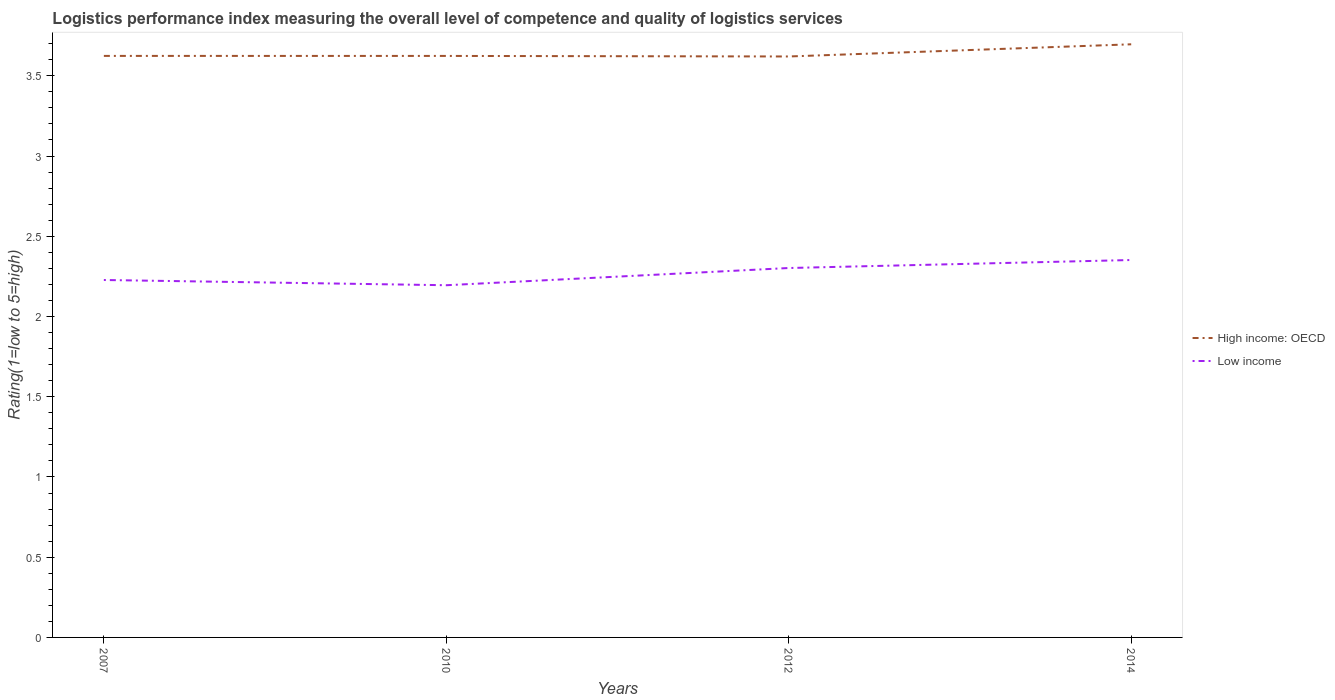How many different coloured lines are there?
Give a very brief answer. 2. Is the number of lines equal to the number of legend labels?
Provide a short and direct response. Yes. Across all years, what is the maximum Logistic performance index in Low income?
Your answer should be very brief. 2.19. In which year was the Logistic performance index in High income: OECD maximum?
Provide a short and direct response. 2012. What is the total Logistic performance index in High income: OECD in the graph?
Offer a very short reply. -0.07. What is the difference between the highest and the second highest Logistic performance index in Low income?
Make the answer very short. 0.16. What is the difference between the highest and the lowest Logistic performance index in High income: OECD?
Offer a very short reply. 1. How many lines are there?
Give a very brief answer. 2. How many years are there in the graph?
Offer a terse response. 4. What is the difference between two consecutive major ticks on the Y-axis?
Offer a very short reply. 0.5. Does the graph contain any zero values?
Offer a very short reply. No. Does the graph contain grids?
Ensure brevity in your answer.  No. How many legend labels are there?
Make the answer very short. 2. How are the legend labels stacked?
Provide a short and direct response. Vertical. What is the title of the graph?
Keep it short and to the point. Logistics performance index measuring the overall level of competence and quality of logistics services. Does "Nicaragua" appear as one of the legend labels in the graph?
Your answer should be compact. No. What is the label or title of the Y-axis?
Give a very brief answer. Rating(1=low to 5=high). What is the Rating(1=low to 5=high) in High income: OECD in 2007?
Keep it short and to the point. 3.62. What is the Rating(1=low to 5=high) in Low income in 2007?
Your response must be concise. 2.23. What is the Rating(1=low to 5=high) of High income: OECD in 2010?
Offer a very short reply. 3.62. What is the Rating(1=low to 5=high) in Low income in 2010?
Give a very brief answer. 2.19. What is the Rating(1=low to 5=high) of High income: OECD in 2012?
Your response must be concise. 3.62. What is the Rating(1=low to 5=high) of Low income in 2012?
Keep it short and to the point. 2.3. What is the Rating(1=low to 5=high) in High income: OECD in 2014?
Offer a very short reply. 3.7. What is the Rating(1=low to 5=high) of Low income in 2014?
Give a very brief answer. 2.35. Across all years, what is the maximum Rating(1=low to 5=high) of High income: OECD?
Ensure brevity in your answer.  3.7. Across all years, what is the maximum Rating(1=low to 5=high) in Low income?
Make the answer very short. 2.35. Across all years, what is the minimum Rating(1=low to 5=high) in High income: OECD?
Provide a succinct answer. 3.62. Across all years, what is the minimum Rating(1=low to 5=high) in Low income?
Your answer should be compact. 2.19. What is the total Rating(1=low to 5=high) in High income: OECD in the graph?
Ensure brevity in your answer.  14.56. What is the total Rating(1=low to 5=high) in Low income in the graph?
Provide a short and direct response. 9.08. What is the difference between the Rating(1=low to 5=high) in High income: OECD in 2007 and that in 2010?
Offer a very short reply. 0. What is the difference between the Rating(1=low to 5=high) in Low income in 2007 and that in 2010?
Give a very brief answer. 0.03. What is the difference between the Rating(1=low to 5=high) in High income: OECD in 2007 and that in 2012?
Provide a succinct answer. 0. What is the difference between the Rating(1=low to 5=high) in Low income in 2007 and that in 2012?
Offer a terse response. -0.07. What is the difference between the Rating(1=low to 5=high) of High income: OECD in 2007 and that in 2014?
Your answer should be compact. -0.07. What is the difference between the Rating(1=low to 5=high) of Low income in 2007 and that in 2014?
Offer a terse response. -0.12. What is the difference between the Rating(1=low to 5=high) in High income: OECD in 2010 and that in 2012?
Ensure brevity in your answer.  0. What is the difference between the Rating(1=low to 5=high) of Low income in 2010 and that in 2012?
Ensure brevity in your answer.  -0.11. What is the difference between the Rating(1=low to 5=high) in High income: OECD in 2010 and that in 2014?
Make the answer very short. -0.07. What is the difference between the Rating(1=low to 5=high) in Low income in 2010 and that in 2014?
Your answer should be compact. -0.16. What is the difference between the Rating(1=low to 5=high) in High income: OECD in 2012 and that in 2014?
Make the answer very short. -0.08. What is the difference between the Rating(1=low to 5=high) of Low income in 2012 and that in 2014?
Your response must be concise. -0.05. What is the difference between the Rating(1=low to 5=high) in High income: OECD in 2007 and the Rating(1=low to 5=high) in Low income in 2010?
Your answer should be compact. 1.43. What is the difference between the Rating(1=low to 5=high) of High income: OECD in 2007 and the Rating(1=low to 5=high) of Low income in 2012?
Offer a terse response. 1.32. What is the difference between the Rating(1=low to 5=high) in High income: OECD in 2007 and the Rating(1=low to 5=high) in Low income in 2014?
Make the answer very short. 1.27. What is the difference between the Rating(1=low to 5=high) of High income: OECD in 2010 and the Rating(1=low to 5=high) of Low income in 2012?
Your response must be concise. 1.32. What is the difference between the Rating(1=low to 5=high) in High income: OECD in 2010 and the Rating(1=low to 5=high) in Low income in 2014?
Your answer should be compact. 1.27. What is the difference between the Rating(1=low to 5=high) of High income: OECD in 2012 and the Rating(1=low to 5=high) of Low income in 2014?
Ensure brevity in your answer.  1.27. What is the average Rating(1=low to 5=high) in High income: OECD per year?
Give a very brief answer. 3.64. What is the average Rating(1=low to 5=high) in Low income per year?
Give a very brief answer. 2.27. In the year 2007, what is the difference between the Rating(1=low to 5=high) of High income: OECD and Rating(1=low to 5=high) of Low income?
Your response must be concise. 1.4. In the year 2010, what is the difference between the Rating(1=low to 5=high) of High income: OECD and Rating(1=low to 5=high) of Low income?
Keep it short and to the point. 1.43. In the year 2012, what is the difference between the Rating(1=low to 5=high) in High income: OECD and Rating(1=low to 5=high) in Low income?
Keep it short and to the point. 1.32. In the year 2014, what is the difference between the Rating(1=low to 5=high) in High income: OECD and Rating(1=low to 5=high) in Low income?
Keep it short and to the point. 1.34. What is the ratio of the Rating(1=low to 5=high) of High income: OECD in 2007 to that in 2010?
Your answer should be very brief. 1. What is the ratio of the Rating(1=low to 5=high) in Low income in 2007 to that in 2010?
Your answer should be very brief. 1.01. What is the ratio of the Rating(1=low to 5=high) in Low income in 2007 to that in 2012?
Offer a very short reply. 0.97. What is the ratio of the Rating(1=low to 5=high) in High income: OECD in 2007 to that in 2014?
Give a very brief answer. 0.98. What is the ratio of the Rating(1=low to 5=high) in Low income in 2007 to that in 2014?
Your response must be concise. 0.95. What is the ratio of the Rating(1=low to 5=high) in Low income in 2010 to that in 2012?
Keep it short and to the point. 0.95. What is the ratio of the Rating(1=low to 5=high) of High income: OECD in 2010 to that in 2014?
Your answer should be compact. 0.98. What is the ratio of the Rating(1=low to 5=high) in Low income in 2010 to that in 2014?
Offer a terse response. 0.93. What is the ratio of the Rating(1=low to 5=high) in High income: OECD in 2012 to that in 2014?
Offer a very short reply. 0.98. What is the ratio of the Rating(1=low to 5=high) of Low income in 2012 to that in 2014?
Offer a terse response. 0.98. What is the difference between the highest and the second highest Rating(1=low to 5=high) of High income: OECD?
Provide a short and direct response. 0.07. What is the difference between the highest and the second highest Rating(1=low to 5=high) of Low income?
Provide a short and direct response. 0.05. What is the difference between the highest and the lowest Rating(1=low to 5=high) of High income: OECD?
Your answer should be compact. 0.08. What is the difference between the highest and the lowest Rating(1=low to 5=high) of Low income?
Your answer should be compact. 0.16. 